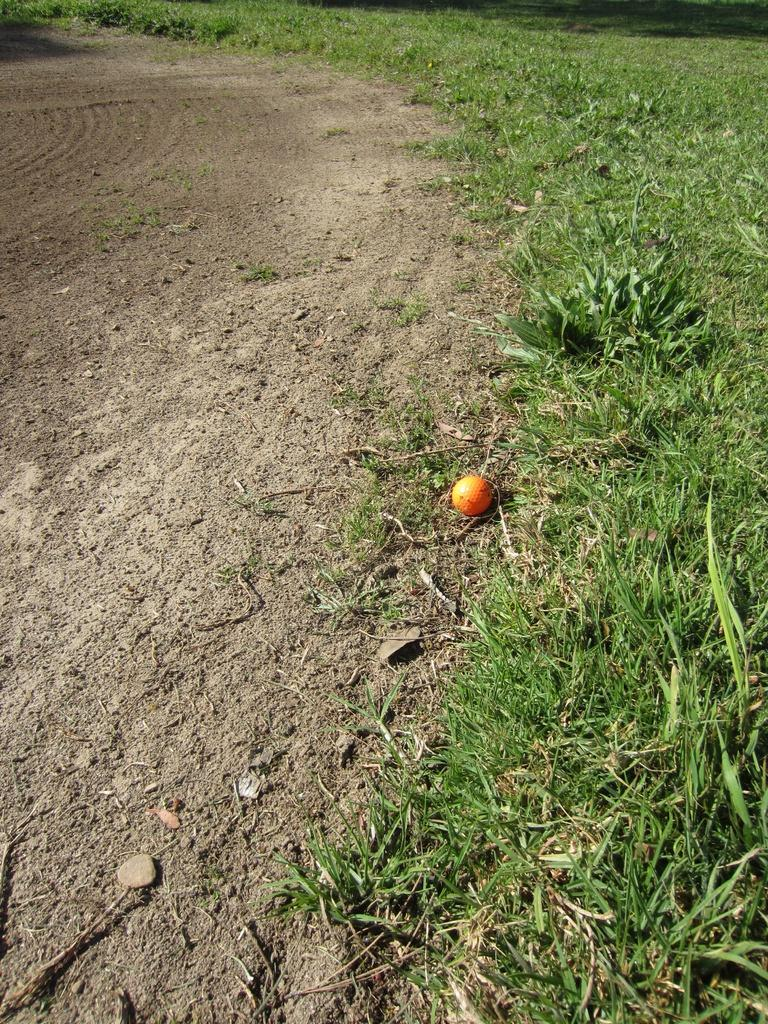What type of vegetation is present on the right side of the image? There is grass on the ground on the right side of the image. What can be found in the center of the image? There is a fruit on the ground in the center of the image. Where is the chair located in the image? There is no chair present in the image. What type of toothbrush can be seen in the image? There is no toothbrush present in the image. 